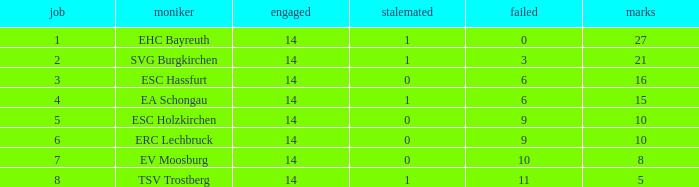What's the deficit when there were over 16 points and had a tie below 1? None. 